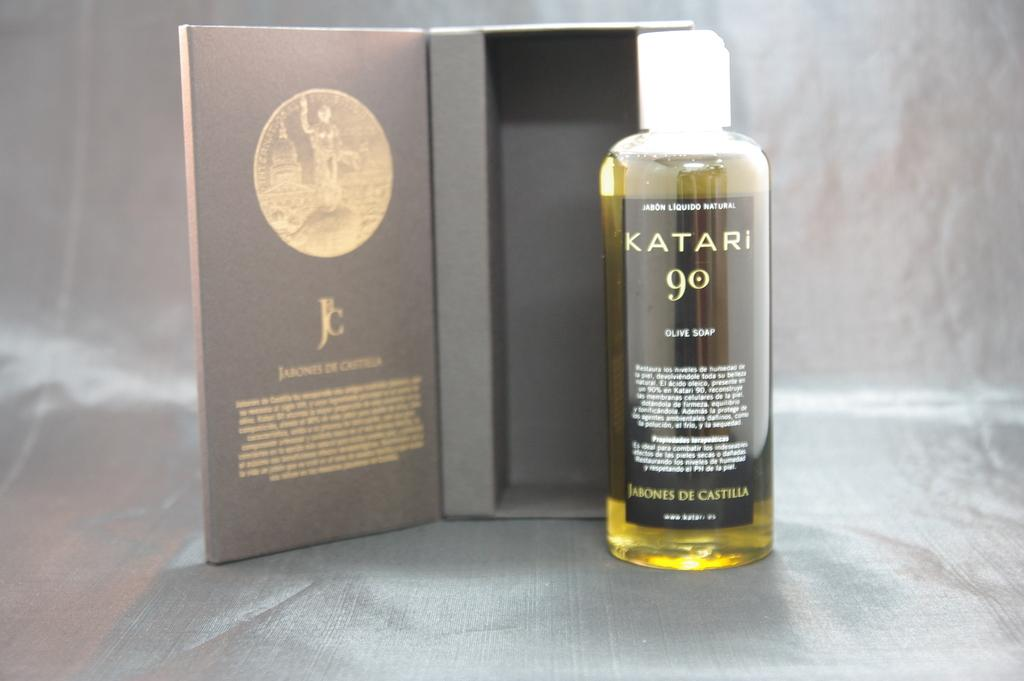<image>
Present a compact description of the photo's key features. A bottle of Katari 90 olive soap is shown outside of a well structured packaging box. 